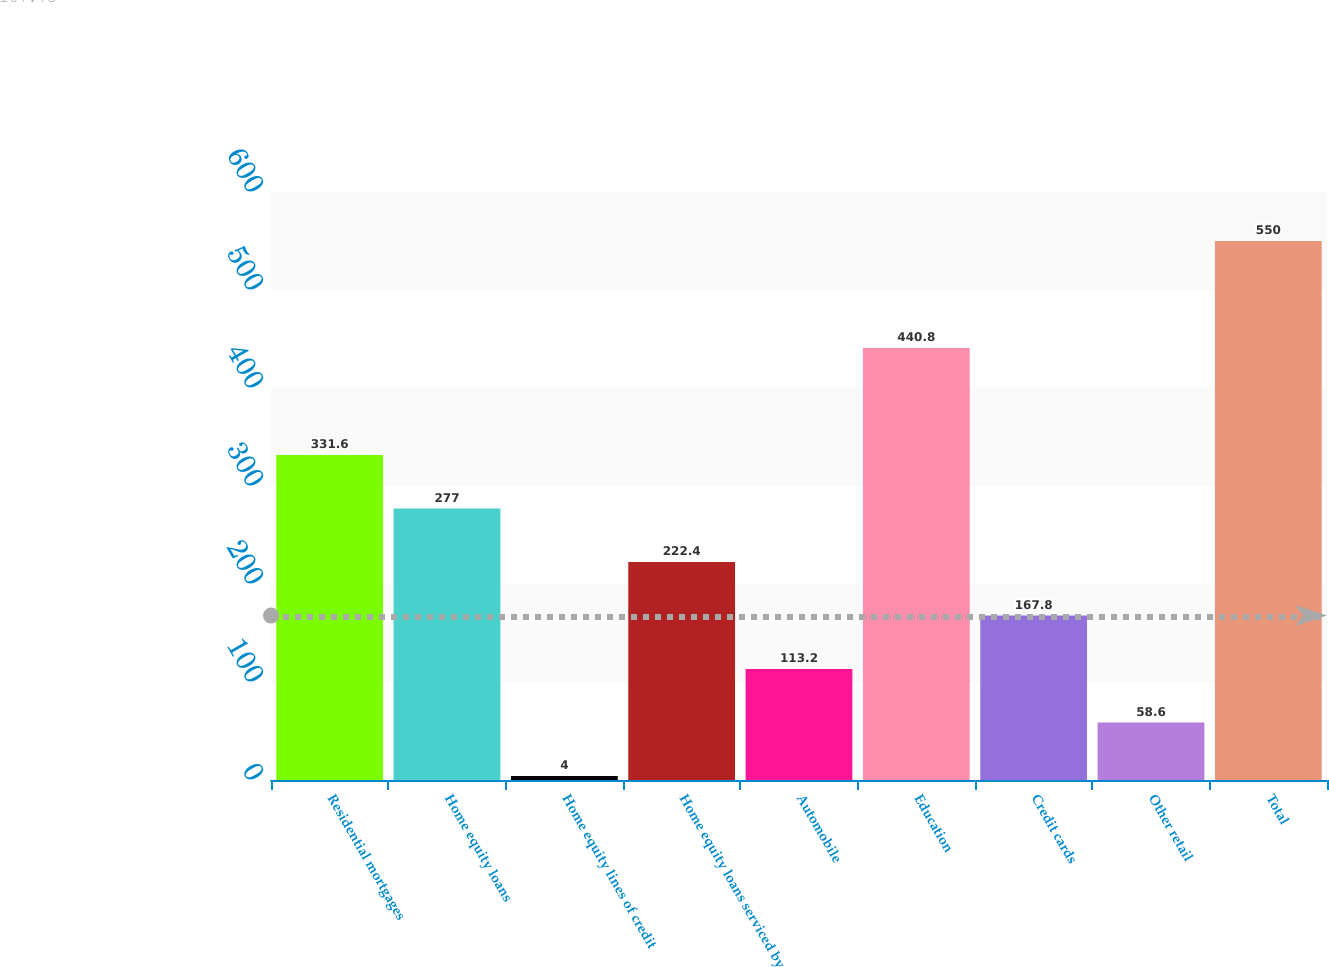<chart> <loc_0><loc_0><loc_500><loc_500><bar_chart><fcel>Residential mortgages<fcel>Home equity loans<fcel>Home equity lines of credit<fcel>Home equity loans serviced by<fcel>Automobile<fcel>Education<fcel>Credit cards<fcel>Other retail<fcel>Total<nl><fcel>331.6<fcel>277<fcel>4<fcel>222.4<fcel>113.2<fcel>440.8<fcel>167.8<fcel>58.6<fcel>550<nl></chart> 